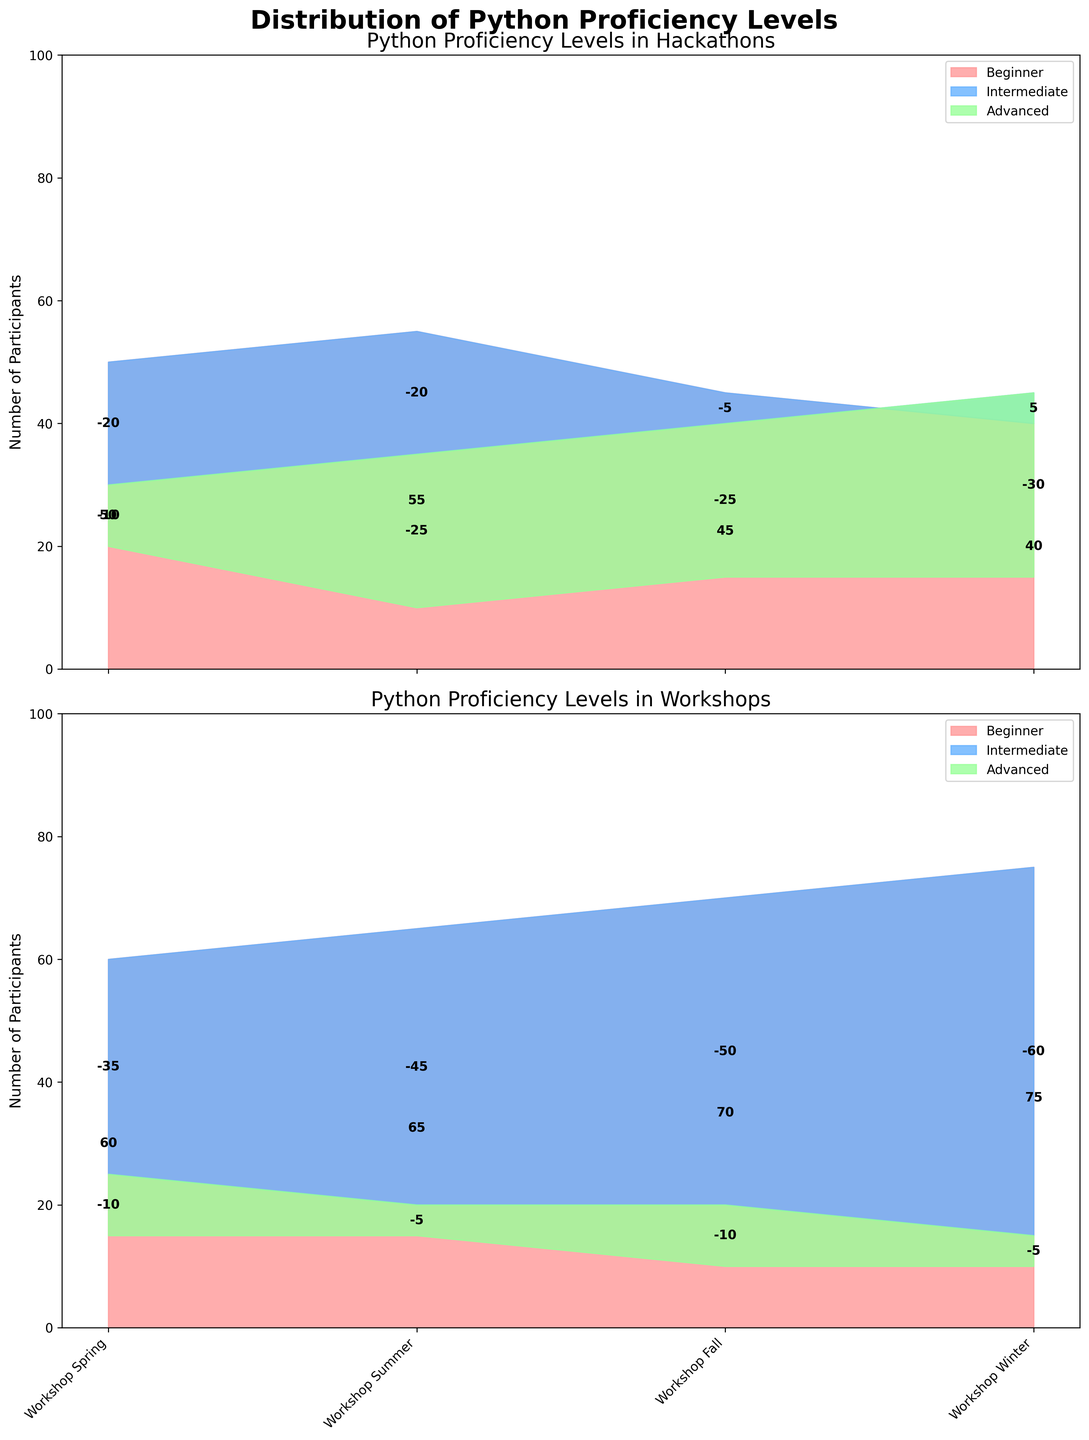What are the titles of the two subplots in the figure? The figure consists of two subplots, each titled to reflect the events being analyzed. The top subplot is titled "Python Proficiency Levels in Hackathons" and the bottom subplot is titled "Python Proficiency Levels in Workshops".
Answer: Python Proficiency Levels in Hackathons; Python Proficiency Levels in Workshops Which event has the highest number of beginner participants in workshops, and how many are there? In the bottom subplot for workshops, the event with the highest number of beginner participants is the "Workshop Winter", where there are 75 beginner participants, as indicated by the height of the area representing beginners.
Answer: Workshop Winter; 75 In Hackathons, between "Hackathon Spring" and "Hackathon Winter", which event has more intermediate participants? Compare the height of the intermediate area (typically in a different color) for these two events in the top subplot. "Hackathon Winter" has 45 intermediate participants, while "Hackathon Spring" has 30 intermediate participants. Therefore, "Hackathon Winter" has more intermediate participants.
Answer: Hackathon Winter What is the range of dates covered by the events in the figure? Examine the x-axis labels for both subplots, which list the events along with their dates. The range begins with "Hackathon Spring" on 2023-03-15 and ends with "Workshop Winter" on 2024-01-20.
Answer: 2023-03-15 to 2024-01-20 Compare the total number of participants in "Hackathon Summer" and "Workshop Summer". Which event had more participants and by how much? Sum the participants for each proficiency level for both events. "Hackathon Summer" has (55 + 35 + 10) = 100 participants while "Workshop Summer" has (65 + 20 + 15) = 100 participants. Both events have the same total number of participants.
Answer: Both have 100 participants What is the dominant proficiency level in "Hackathon Fall"? Observe the height of the areas in the top subplot for "Hackathon Fall". The area representing intermediate participants is the largest, indicating that intermediate is the dominant proficiency level in this event.
Answer: Intermediate Which event has the smallest number of advanced participants and how many are there? Identify the smallest area representing advanced participants across all events in both subplots. "Hackathon Summer" and "Workshop Fall" both have the smallest number of advanced participants with only 10 participants each.
Answer: Hackathon Summer and Workshop Fall; 10 How does the number of advanced participants in "Workshop Summer" compare to "Workshop Spring"? Compare the height of the advanced area in the bottom subplot for the two events. "Workshop Summer" has 15 advanced participants and "Workshop Spring" also has 15 advanced participants.
Answer: Equal (15 each) What trend can be observed in the number of beginner participants in Hackathons over the year? Track the height of the beginner areas in the top subplot across different Hackathon events. The number of beginner participants starts at 50 in "Hackathon Spring," increases to 55 in "Hackathon Summer," then decreases to 45 in "Hackathon Fall," and further decreases to 40 in "Hackathon Winter."
Answer: Decreasing Which subplot shows a more varied distribution in proficiency levels overall, Hackathons or Workshops? Assess the variation in heights of different areas within each subplot. In Workshops, the distributions show more significant differences across events, with more pronounced changes in the height of the beginner, intermediate, and advanced areas. This indicates a more varied distribution.
Answer: Workshops 